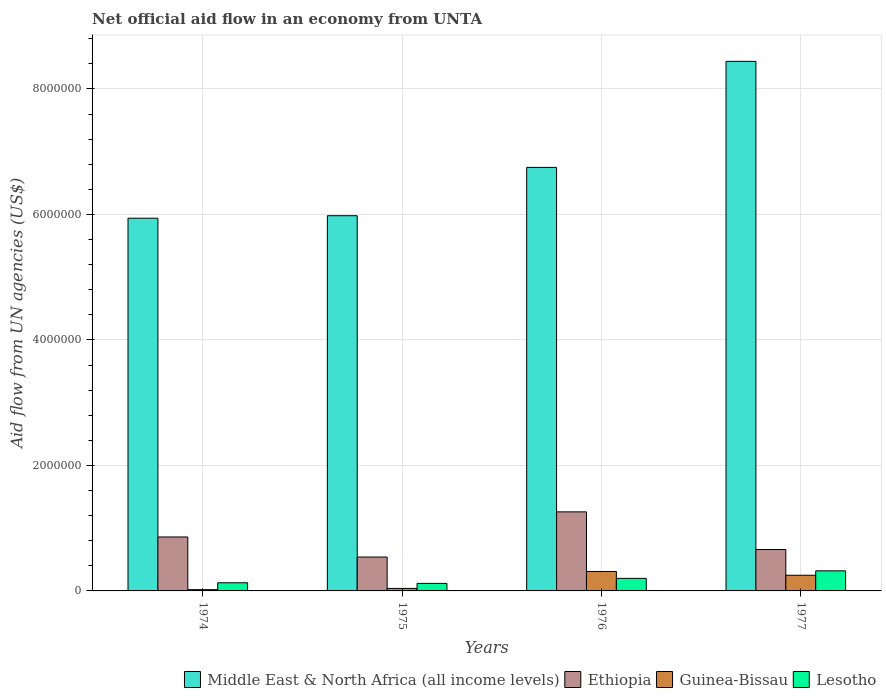How many groups of bars are there?
Give a very brief answer. 4. Are the number of bars per tick equal to the number of legend labels?
Keep it short and to the point. Yes. Are the number of bars on each tick of the X-axis equal?
Your answer should be very brief. Yes. How many bars are there on the 3rd tick from the right?
Provide a short and direct response. 4. What is the label of the 3rd group of bars from the left?
Offer a very short reply. 1976. In how many cases, is the number of bars for a given year not equal to the number of legend labels?
Give a very brief answer. 0. What is the net official aid flow in Middle East & North Africa (all income levels) in 1974?
Keep it short and to the point. 5.94e+06. In which year was the net official aid flow in Guinea-Bissau maximum?
Offer a terse response. 1976. In which year was the net official aid flow in Ethiopia minimum?
Keep it short and to the point. 1975. What is the total net official aid flow in Middle East & North Africa (all income levels) in the graph?
Offer a terse response. 2.71e+07. What is the difference between the net official aid flow in Lesotho in 1976 and that in 1977?
Offer a very short reply. -1.20e+05. What is the difference between the net official aid flow in Guinea-Bissau in 1976 and the net official aid flow in Middle East & North Africa (all income levels) in 1974?
Keep it short and to the point. -5.63e+06. What is the average net official aid flow in Lesotho per year?
Provide a succinct answer. 1.92e+05. In the year 1974, what is the difference between the net official aid flow in Ethiopia and net official aid flow in Middle East & North Africa (all income levels)?
Your response must be concise. -5.08e+06. In how many years, is the net official aid flow in Lesotho greater than 5600000 US$?
Make the answer very short. 0. What is the ratio of the net official aid flow in Guinea-Bissau in 1976 to that in 1977?
Offer a very short reply. 1.24. Is the net official aid flow in Ethiopia in 1974 less than that in 1975?
Give a very brief answer. No. Is the difference between the net official aid flow in Ethiopia in 1974 and 1976 greater than the difference between the net official aid flow in Middle East & North Africa (all income levels) in 1974 and 1976?
Keep it short and to the point. Yes. What is the difference between the highest and the lowest net official aid flow in Middle East & North Africa (all income levels)?
Offer a very short reply. 2.50e+06. Is the sum of the net official aid flow in Middle East & North Africa (all income levels) in 1974 and 1976 greater than the maximum net official aid flow in Guinea-Bissau across all years?
Provide a succinct answer. Yes. What does the 1st bar from the left in 1975 represents?
Keep it short and to the point. Middle East & North Africa (all income levels). What does the 3rd bar from the right in 1974 represents?
Your answer should be compact. Ethiopia. Are all the bars in the graph horizontal?
Give a very brief answer. No. Does the graph contain any zero values?
Provide a short and direct response. No. Does the graph contain grids?
Your response must be concise. Yes. Where does the legend appear in the graph?
Ensure brevity in your answer.  Bottom right. What is the title of the graph?
Ensure brevity in your answer.  Net official aid flow in an economy from UNTA. What is the label or title of the Y-axis?
Give a very brief answer. Aid flow from UN agencies (US$). What is the Aid flow from UN agencies (US$) of Middle East & North Africa (all income levels) in 1974?
Offer a terse response. 5.94e+06. What is the Aid flow from UN agencies (US$) of Ethiopia in 1974?
Your answer should be compact. 8.60e+05. What is the Aid flow from UN agencies (US$) in Guinea-Bissau in 1974?
Keep it short and to the point. 2.00e+04. What is the Aid flow from UN agencies (US$) of Middle East & North Africa (all income levels) in 1975?
Provide a succinct answer. 5.98e+06. What is the Aid flow from UN agencies (US$) of Ethiopia in 1975?
Ensure brevity in your answer.  5.40e+05. What is the Aid flow from UN agencies (US$) in Guinea-Bissau in 1975?
Give a very brief answer. 4.00e+04. What is the Aid flow from UN agencies (US$) in Middle East & North Africa (all income levels) in 1976?
Your response must be concise. 6.75e+06. What is the Aid flow from UN agencies (US$) in Ethiopia in 1976?
Your response must be concise. 1.26e+06. What is the Aid flow from UN agencies (US$) in Guinea-Bissau in 1976?
Ensure brevity in your answer.  3.10e+05. What is the Aid flow from UN agencies (US$) in Lesotho in 1976?
Give a very brief answer. 2.00e+05. What is the Aid flow from UN agencies (US$) of Middle East & North Africa (all income levels) in 1977?
Keep it short and to the point. 8.44e+06. What is the Aid flow from UN agencies (US$) of Ethiopia in 1977?
Offer a terse response. 6.60e+05. What is the Aid flow from UN agencies (US$) of Guinea-Bissau in 1977?
Give a very brief answer. 2.50e+05. What is the Aid flow from UN agencies (US$) of Lesotho in 1977?
Make the answer very short. 3.20e+05. Across all years, what is the maximum Aid flow from UN agencies (US$) of Middle East & North Africa (all income levels)?
Your response must be concise. 8.44e+06. Across all years, what is the maximum Aid flow from UN agencies (US$) in Ethiopia?
Your answer should be compact. 1.26e+06. Across all years, what is the maximum Aid flow from UN agencies (US$) in Guinea-Bissau?
Your answer should be compact. 3.10e+05. Across all years, what is the maximum Aid flow from UN agencies (US$) of Lesotho?
Give a very brief answer. 3.20e+05. Across all years, what is the minimum Aid flow from UN agencies (US$) in Middle East & North Africa (all income levels)?
Ensure brevity in your answer.  5.94e+06. Across all years, what is the minimum Aid flow from UN agencies (US$) of Ethiopia?
Make the answer very short. 5.40e+05. What is the total Aid flow from UN agencies (US$) in Middle East & North Africa (all income levels) in the graph?
Provide a succinct answer. 2.71e+07. What is the total Aid flow from UN agencies (US$) of Ethiopia in the graph?
Provide a short and direct response. 3.32e+06. What is the total Aid flow from UN agencies (US$) of Guinea-Bissau in the graph?
Your response must be concise. 6.20e+05. What is the total Aid flow from UN agencies (US$) of Lesotho in the graph?
Provide a succinct answer. 7.70e+05. What is the difference between the Aid flow from UN agencies (US$) in Ethiopia in 1974 and that in 1975?
Ensure brevity in your answer.  3.20e+05. What is the difference between the Aid flow from UN agencies (US$) of Middle East & North Africa (all income levels) in 1974 and that in 1976?
Give a very brief answer. -8.10e+05. What is the difference between the Aid flow from UN agencies (US$) of Ethiopia in 1974 and that in 1976?
Give a very brief answer. -4.00e+05. What is the difference between the Aid flow from UN agencies (US$) in Guinea-Bissau in 1974 and that in 1976?
Offer a very short reply. -2.90e+05. What is the difference between the Aid flow from UN agencies (US$) in Lesotho in 1974 and that in 1976?
Ensure brevity in your answer.  -7.00e+04. What is the difference between the Aid flow from UN agencies (US$) in Middle East & North Africa (all income levels) in 1974 and that in 1977?
Offer a terse response. -2.50e+06. What is the difference between the Aid flow from UN agencies (US$) in Ethiopia in 1974 and that in 1977?
Your response must be concise. 2.00e+05. What is the difference between the Aid flow from UN agencies (US$) of Guinea-Bissau in 1974 and that in 1977?
Offer a terse response. -2.30e+05. What is the difference between the Aid flow from UN agencies (US$) in Lesotho in 1974 and that in 1977?
Give a very brief answer. -1.90e+05. What is the difference between the Aid flow from UN agencies (US$) in Middle East & North Africa (all income levels) in 1975 and that in 1976?
Your response must be concise. -7.70e+05. What is the difference between the Aid flow from UN agencies (US$) of Ethiopia in 1975 and that in 1976?
Offer a terse response. -7.20e+05. What is the difference between the Aid flow from UN agencies (US$) in Lesotho in 1975 and that in 1976?
Your answer should be very brief. -8.00e+04. What is the difference between the Aid flow from UN agencies (US$) of Middle East & North Africa (all income levels) in 1975 and that in 1977?
Give a very brief answer. -2.46e+06. What is the difference between the Aid flow from UN agencies (US$) of Ethiopia in 1975 and that in 1977?
Offer a very short reply. -1.20e+05. What is the difference between the Aid flow from UN agencies (US$) of Guinea-Bissau in 1975 and that in 1977?
Ensure brevity in your answer.  -2.10e+05. What is the difference between the Aid flow from UN agencies (US$) in Middle East & North Africa (all income levels) in 1976 and that in 1977?
Provide a short and direct response. -1.69e+06. What is the difference between the Aid flow from UN agencies (US$) in Guinea-Bissau in 1976 and that in 1977?
Provide a succinct answer. 6.00e+04. What is the difference between the Aid flow from UN agencies (US$) of Lesotho in 1976 and that in 1977?
Offer a terse response. -1.20e+05. What is the difference between the Aid flow from UN agencies (US$) in Middle East & North Africa (all income levels) in 1974 and the Aid flow from UN agencies (US$) in Ethiopia in 1975?
Make the answer very short. 5.40e+06. What is the difference between the Aid flow from UN agencies (US$) in Middle East & North Africa (all income levels) in 1974 and the Aid flow from UN agencies (US$) in Guinea-Bissau in 1975?
Ensure brevity in your answer.  5.90e+06. What is the difference between the Aid flow from UN agencies (US$) in Middle East & North Africa (all income levels) in 1974 and the Aid flow from UN agencies (US$) in Lesotho in 1975?
Offer a very short reply. 5.82e+06. What is the difference between the Aid flow from UN agencies (US$) of Ethiopia in 1974 and the Aid flow from UN agencies (US$) of Guinea-Bissau in 1975?
Give a very brief answer. 8.20e+05. What is the difference between the Aid flow from UN agencies (US$) of Ethiopia in 1974 and the Aid flow from UN agencies (US$) of Lesotho in 1975?
Your answer should be compact. 7.40e+05. What is the difference between the Aid flow from UN agencies (US$) in Middle East & North Africa (all income levels) in 1974 and the Aid flow from UN agencies (US$) in Ethiopia in 1976?
Ensure brevity in your answer.  4.68e+06. What is the difference between the Aid flow from UN agencies (US$) in Middle East & North Africa (all income levels) in 1974 and the Aid flow from UN agencies (US$) in Guinea-Bissau in 1976?
Make the answer very short. 5.63e+06. What is the difference between the Aid flow from UN agencies (US$) in Middle East & North Africa (all income levels) in 1974 and the Aid flow from UN agencies (US$) in Lesotho in 1976?
Keep it short and to the point. 5.74e+06. What is the difference between the Aid flow from UN agencies (US$) in Ethiopia in 1974 and the Aid flow from UN agencies (US$) in Lesotho in 1976?
Provide a short and direct response. 6.60e+05. What is the difference between the Aid flow from UN agencies (US$) of Guinea-Bissau in 1974 and the Aid flow from UN agencies (US$) of Lesotho in 1976?
Offer a very short reply. -1.80e+05. What is the difference between the Aid flow from UN agencies (US$) of Middle East & North Africa (all income levels) in 1974 and the Aid flow from UN agencies (US$) of Ethiopia in 1977?
Make the answer very short. 5.28e+06. What is the difference between the Aid flow from UN agencies (US$) of Middle East & North Africa (all income levels) in 1974 and the Aid flow from UN agencies (US$) of Guinea-Bissau in 1977?
Give a very brief answer. 5.69e+06. What is the difference between the Aid flow from UN agencies (US$) in Middle East & North Africa (all income levels) in 1974 and the Aid flow from UN agencies (US$) in Lesotho in 1977?
Keep it short and to the point. 5.62e+06. What is the difference between the Aid flow from UN agencies (US$) of Ethiopia in 1974 and the Aid flow from UN agencies (US$) of Lesotho in 1977?
Provide a succinct answer. 5.40e+05. What is the difference between the Aid flow from UN agencies (US$) of Guinea-Bissau in 1974 and the Aid flow from UN agencies (US$) of Lesotho in 1977?
Provide a short and direct response. -3.00e+05. What is the difference between the Aid flow from UN agencies (US$) in Middle East & North Africa (all income levels) in 1975 and the Aid flow from UN agencies (US$) in Ethiopia in 1976?
Ensure brevity in your answer.  4.72e+06. What is the difference between the Aid flow from UN agencies (US$) of Middle East & North Africa (all income levels) in 1975 and the Aid flow from UN agencies (US$) of Guinea-Bissau in 1976?
Your response must be concise. 5.67e+06. What is the difference between the Aid flow from UN agencies (US$) of Middle East & North Africa (all income levels) in 1975 and the Aid flow from UN agencies (US$) of Lesotho in 1976?
Offer a terse response. 5.78e+06. What is the difference between the Aid flow from UN agencies (US$) in Middle East & North Africa (all income levels) in 1975 and the Aid flow from UN agencies (US$) in Ethiopia in 1977?
Ensure brevity in your answer.  5.32e+06. What is the difference between the Aid flow from UN agencies (US$) in Middle East & North Africa (all income levels) in 1975 and the Aid flow from UN agencies (US$) in Guinea-Bissau in 1977?
Ensure brevity in your answer.  5.73e+06. What is the difference between the Aid flow from UN agencies (US$) in Middle East & North Africa (all income levels) in 1975 and the Aid flow from UN agencies (US$) in Lesotho in 1977?
Offer a very short reply. 5.66e+06. What is the difference between the Aid flow from UN agencies (US$) of Ethiopia in 1975 and the Aid flow from UN agencies (US$) of Lesotho in 1977?
Offer a very short reply. 2.20e+05. What is the difference between the Aid flow from UN agencies (US$) in Guinea-Bissau in 1975 and the Aid flow from UN agencies (US$) in Lesotho in 1977?
Offer a very short reply. -2.80e+05. What is the difference between the Aid flow from UN agencies (US$) in Middle East & North Africa (all income levels) in 1976 and the Aid flow from UN agencies (US$) in Ethiopia in 1977?
Offer a very short reply. 6.09e+06. What is the difference between the Aid flow from UN agencies (US$) of Middle East & North Africa (all income levels) in 1976 and the Aid flow from UN agencies (US$) of Guinea-Bissau in 1977?
Your answer should be compact. 6.50e+06. What is the difference between the Aid flow from UN agencies (US$) of Middle East & North Africa (all income levels) in 1976 and the Aid flow from UN agencies (US$) of Lesotho in 1977?
Offer a terse response. 6.43e+06. What is the difference between the Aid flow from UN agencies (US$) in Ethiopia in 1976 and the Aid flow from UN agencies (US$) in Guinea-Bissau in 1977?
Your answer should be compact. 1.01e+06. What is the difference between the Aid flow from UN agencies (US$) of Ethiopia in 1976 and the Aid flow from UN agencies (US$) of Lesotho in 1977?
Keep it short and to the point. 9.40e+05. What is the average Aid flow from UN agencies (US$) in Middle East & North Africa (all income levels) per year?
Your answer should be compact. 6.78e+06. What is the average Aid flow from UN agencies (US$) in Ethiopia per year?
Ensure brevity in your answer.  8.30e+05. What is the average Aid flow from UN agencies (US$) in Guinea-Bissau per year?
Make the answer very short. 1.55e+05. What is the average Aid flow from UN agencies (US$) of Lesotho per year?
Keep it short and to the point. 1.92e+05. In the year 1974, what is the difference between the Aid flow from UN agencies (US$) in Middle East & North Africa (all income levels) and Aid flow from UN agencies (US$) in Ethiopia?
Give a very brief answer. 5.08e+06. In the year 1974, what is the difference between the Aid flow from UN agencies (US$) in Middle East & North Africa (all income levels) and Aid flow from UN agencies (US$) in Guinea-Bissau?
Ensure brevity in your answer.  5.92e+06. In the year 1974, what is the difference between the Aid flow from UN agencies (US$) in Middle East & North Africa (all income levels) and Aid flow from UN agencies (US$) in Lesotho?
Provide a short and direct response. 5.81e+06. In the year 1974, what is the difference between the Aid flow from UN agencies (US$) in Ethiopia and Aid flow from UN agencies (US$) in Guinea-Bissau?
Make the answer very short. 8.40e+05. In the year 1974, what is the difference between the Aid flow from UN agencies (US$) of Ethiopia and Aid flow from UN agencies (US$) of Lesotho?
Make the answer very short. 7.30e+05. In the year 1974, what is the difference between the Aid flow from UN agencies (US$) of Guinea-Bissau and Aid flow from UN agencies (US$) of Lesotho?
Your answer should be compact. -1.10e+05. In the year 1975, what is the difference between the Aid flow from UN agencies (US$) in Middle East & North Africa (all income levels) and Aid flow from UN agencies (US$) in Ethiopia?
Offer a very short reply. 5.44e+06. In the year 1975, what is the difference between the Aid flow from UN agencies (US$) in Middle East & North Africa (all income levels) and Aid flow from UN agencies (US$) in Guinea-Bissau?
Provide a short and direct response. 5.94e+06. In the year 1975, what is the difference between the Aid flow from UN agencies (US$) of Middle East & North Africa (all income levels) and Aid flow from UN agencies (US$) of Lesotho?
Make the answer very short. 5.86e+06. In the year 1975, what is the difference between the Aid flow from UN agencies (US$) in Ethiopia and Aid flow from UN agencies (US$) in Guinea-Bissau?
Provide a succinct answer. 5.00e+05. In the year 1975, what is the difference between the Aid flow from UN agencies (US$) of Ethiopia and Aid flow from UN agencies (US$) of Lesotho?
Offer a very short reply. 4.20e+05. In the year 1976, what is the difference between the Aid flow from UN agencies (US$) in Middle East & North Africa (all income levels) and Aid flow from UN agencies (US$) in Ethiopia?
Ensure brevity in your answer.  5.49e+06. In the year 1976, what is the difference between the Aid flow from UN agencies (US$) of Middle East & North Africa (all income levels) and Aid flow from UN agencies (US$) of Guinea-Bissau?
Provide a short and direct response. 6.44e+06. In the year 1976, what is the difference between the Aid flow from UN agencies (US$) in Middle East & North Africa (all income levels) and Aid flow from UN agencies (US$) in Lesotho?
Your answer should be very brief. 6.55e+06. In the year 1976, what is the difference between the Aid flow from UN agencies (US$) of Ethiopia and Aid flow from UN agencies (US$) of Guinea-Bissau?
Provide a succinct answer. 9.50e+05. In the year 1976, what is the difference between the Aid flow from UN agencies (US$) in Ethiopia and Aid flow from UN agencies (US$) in Lesotho?
Offer a terse response. 1.06e+06. In the year 1977, what is the difference between the Aid flow from UN agencies (US$) of Middle East & North Africa (all income levels) and Aid flow from UN agencies (US$) of Ethiopia?
Provide a succinct answer. 7.78e+06. In the year 1977, what is the difference between the Aid flow from UN agencies (US$) of Middle East & North Africa (all income levels) and Aid flow from UN agencies (US$) of Guinea-Bissau?
Give a very brief answer. 8.19e+06. In the year 1977, what is the difference between the Aid flow from UN agencies (US$) in Middle East & North Africa (all income levels) and Aid flow from UN agencies (US$) in Lesotho?
Provide a succinct answer. 8.12e+06. In the year 1977, what is the difference between the Aid flow from UN agencies (US$) in Ethiopia and Aid flow from UN agencies (US$) in Guinea-Bissau?
Offer a very short reply. 4.10e+05. What is the ratio of the Aid flow from UN agencies (US$) of Middle East & North Africa (all income levels) in 1974 to that in 1975?
Your response must be concise. 0.99. What is the ratio of the Aid flow from UN agencies (US$) in Ethiopia in 1974 to that in 1975?
Keep it short and to the point. 1.59. What is the ratio of the Aid flow from UN agencies (US$) of Lesotho in 1974 to that in 1975?
Offer a terse response. 1.08. What is the ratio of the Aid flow from UN agencies (US$) of Middle East & North Africa (all income levels) in 1974 to that in 1976?
Your response must be concise. 0.88. What is the ratio of the Aid flow from UN agencies (US$) of Ethiopia in 1974 to that in 1976?
Offer a very short reply. 0.68. What is the ratio of the Aid flow from UN agencies (US$) of Guinea-Bissau in 1974 to that in 1976?
Give a very brief answer. 0.06. What is the ratio of the Aid flow from UN agencies (US$) of Lesotho in 1974 to that in 1976?
Provide a succinct answer. 0.65. What is the ratio of the Aid flow from UN agencies (US$) of Middle East & North Africa (all income levels) in 1974 to that in 1977?
Your answer should be very brief. 0.7. What is the ratio of the Aid flow from UN agencies (US$) in Ethiopia in 1974 to that in 1977?
Your response must be concise. 1.3. What is the ratio of the Aid flow from UN agencies (US$) in Guinea-Bissau in 1974 to that in 1977?
Provide a short and direct response. 0.08. What is the ratio of the Aid flow from UN agencies (US$) in Lesotho in 1974 to that in 1977?
Ensure brevity in your answer.  0.41. What is the ratio of the Aid flow from UN agencies (US$) of Middle East & North Africa (all income levels) in 1975 to that in 1976?
Give a very brief answer. 0.89. What is the ratio of the Aid flow from UN agencies (US$) in Ethiopia in 1975 to that in 1976?
Offer a very short reply. 0.43. What is the ratio of the Aid flow from UN agencies (US$) of Guinea-Bissau in 1975 to that in 1976?
Provide a succinct answer. 0.13. What is the ratio of the Aid flow from UN agencies (US$) in Lesotho in 1975 to that in 1976?
Offer a terse response. 0.6. What is the ratio of the Aid flow from UN agencies (US$) of Middle East & North Africa (all income levels) in 1975 to that in 1977?
Your response must be concise. 0.71. What is the ratio of the Aid flow from UN agencies (US$) of Ethiopia in 1975 to that in 1977?
Provide a short and direct response. 0.82. What is the ratio of the Aid flow from UN agencies (US$) in Guinea-Bissau in 1975 to that in 1977?
Ensure brevity in your answer.  0.16. What is the ratio of the Aid flow from UN agencies (US$) in Lesotho in 1975 to that in 1977?
Offer a very short reply. 0.38. What is the ratio of the Aid flow from UN agencies (US$) of Middle East & North Africa (all income levels) in 1976 to that in 1977?
Provide a succinct answer. 0.8. What is the ratio of the Aid flow from UN agencies (US$) of Ethiopia in 1976 to that in 1977?
Make the answer very short. 1.91. What is the ratio of the Aid flow from UN agencies (US$) of Guinea-Bissau in 1976 to that in 1977?
Ensure brevity in your answer.  1.24. What is the difference between the highest and the second highest Aid flow from UN agencies (US$) of Middle East & North Africa (all income levels)?
Provide a succinct answer. 1.69e+06. What is the difference between the highest and the second highest Aid flow from UN agencies (US$) in Guinea-Bissau?
Provide a short and direct response. 6.00e+04. What is the difference between the highest and the second highest Aid flow from UN agencies (US$) of Lesotho?
Give a very brief answer. 1.20e+05. What is the difference between the highest and the lowest Aid flow from UN agencies (US$) of Middle East & North Africa (all income levels)?
Keep it short and to the point. 2.50e+06. What is the difference between the highest and the lowest Aid flow from UN agencies (US$) of Ethiopia?
Provide a succinct answer. 7.20e+05. What is the difference between the highest and the lowest Aid flow from UN agencies (US$) in Guinea-Bissau?
Keep it short and to the point. 2.90e+05. 